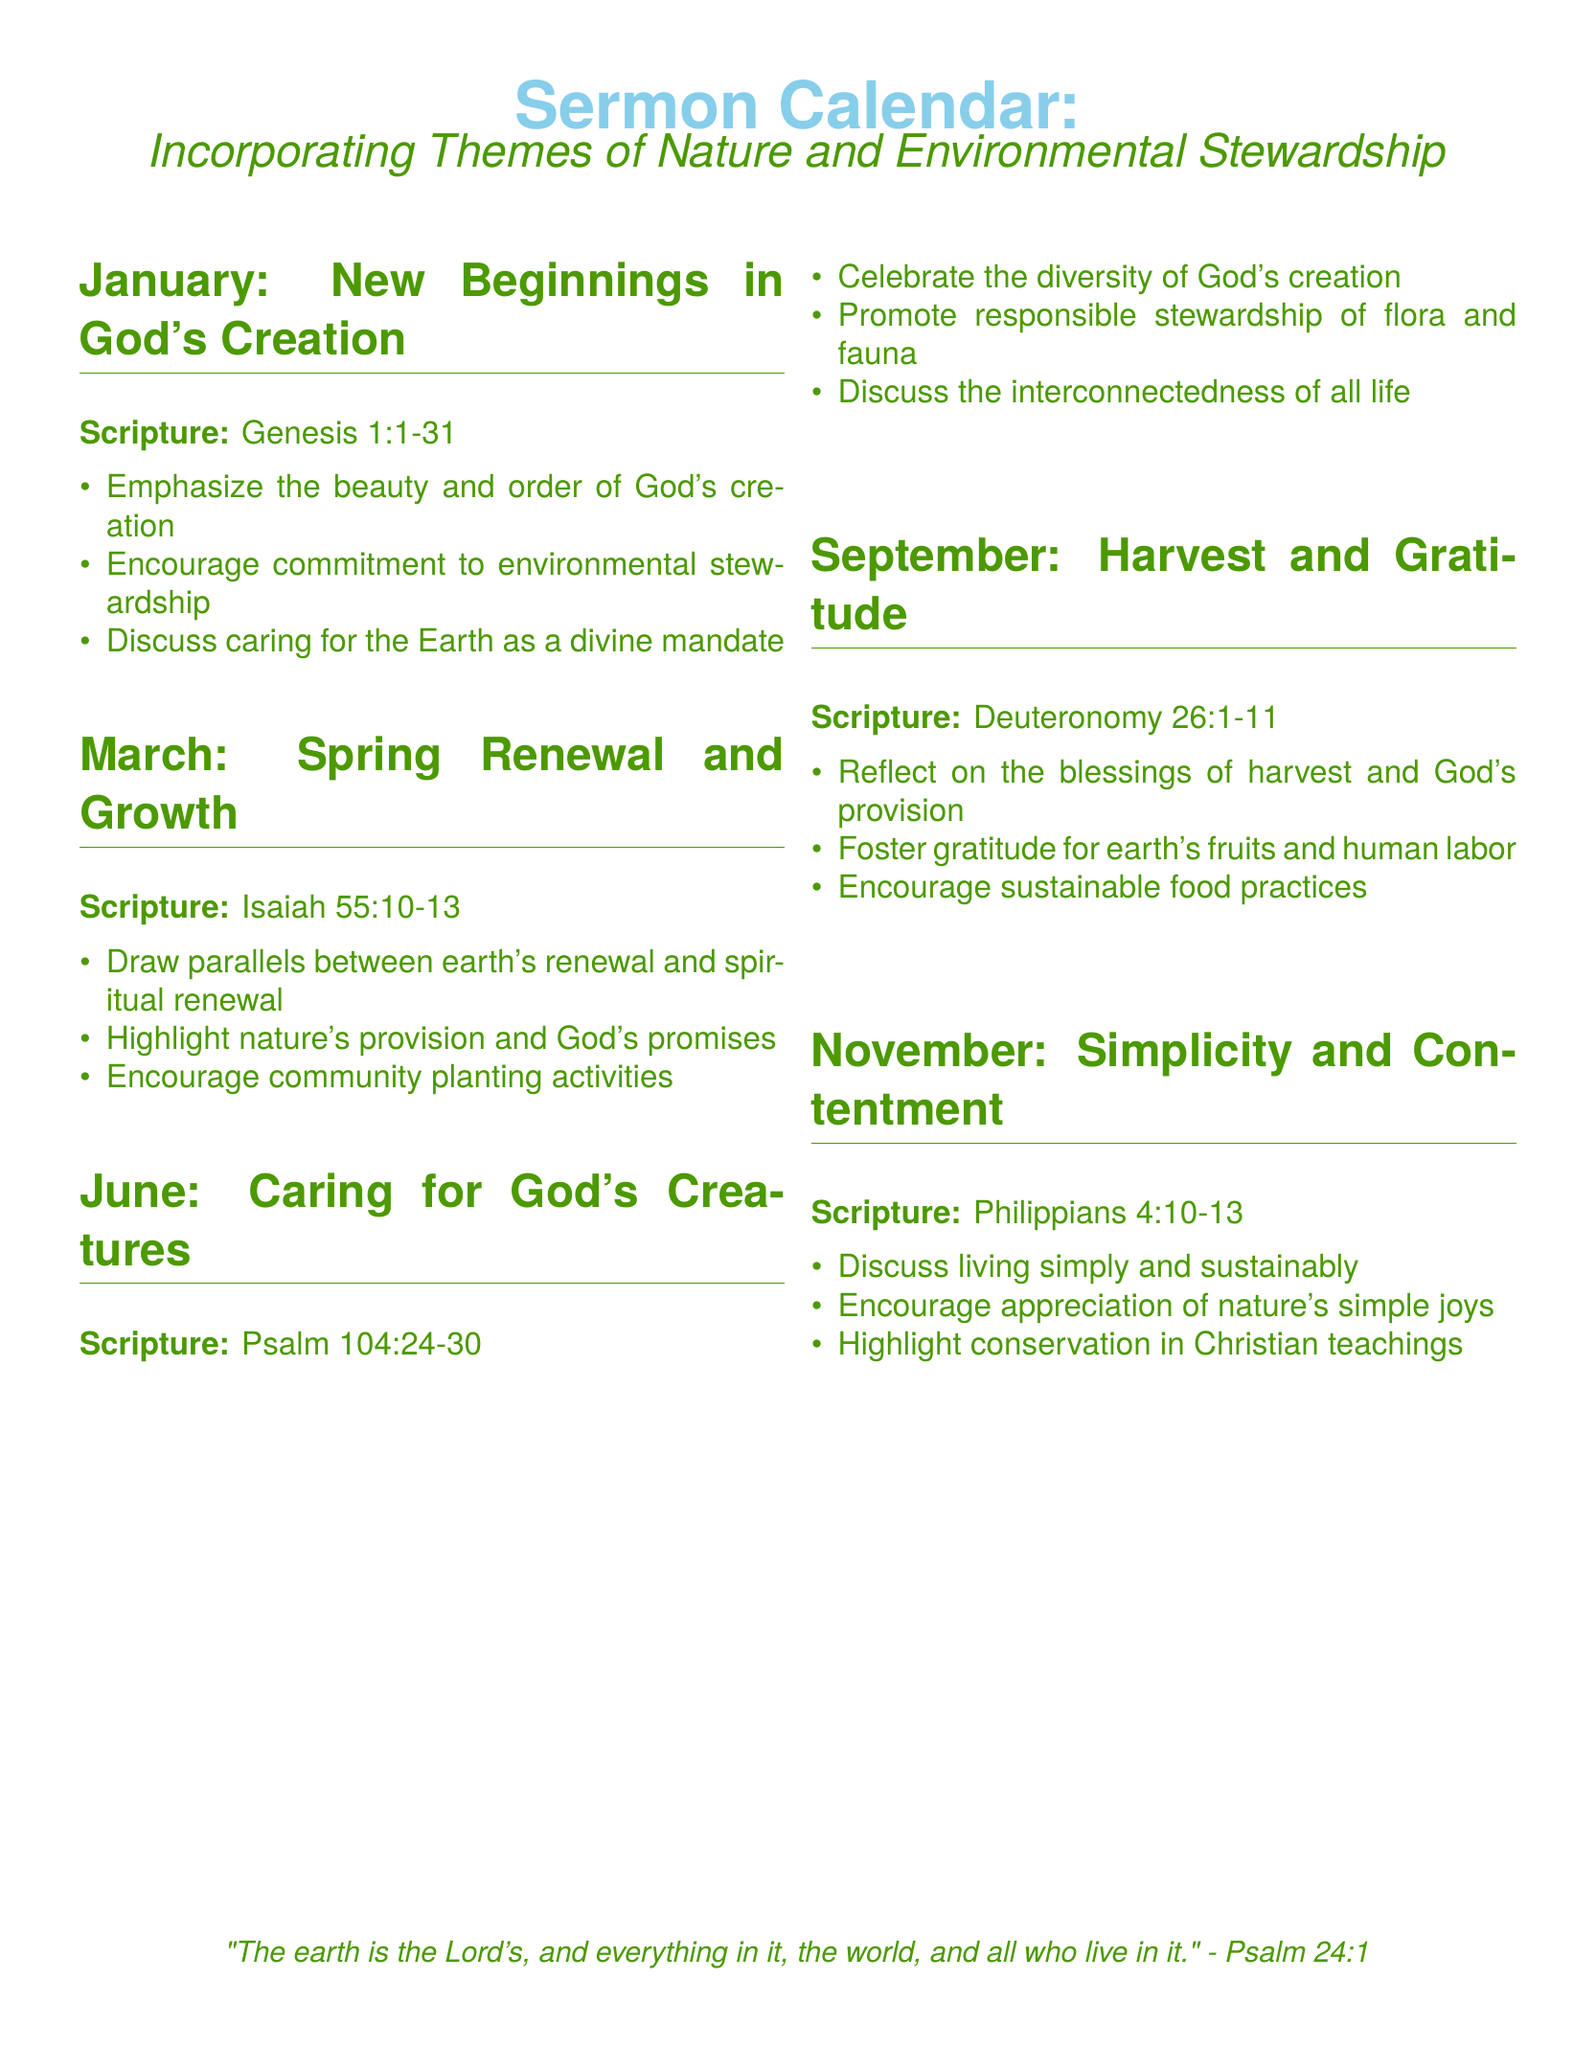What is the scripture for January? The document lists Genesis 1:1-31 as the scripture for January.
Answer: Genesis 1:1-31 What theme is emphasized in June? The theme for June focuses on caring for God's creatures.
Answer: Caring for God's Creatures Which month focuses on gratitude? The document states that November is dedicated to simplicity and contentment, while September focuses on gratitude.
Answer: September What scripture is associated with the theme of Spring Renewal and Growth? Isaiah 55:10-13 is the scripture paired with the theme of Spring Renewal and Growth.
Answer: Isaiah 55:10-13 What is mentioned as a community activity in March? The document suggests encouraging community planting activities in March.
Answer: Community planting activities What should be reflected on in September? The document advises reflecting on the blessings of harvest and God's provision in September.
Answer: Blessings of harvest Which scripture emphasizes the beauty of the Earth? Genesis 1:1-31 emphasizes the beauty and order of God's creation.
Answer: Genesis 1:1-31 